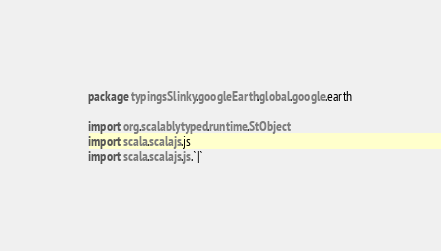<code> <loc_0><loc_0><loc_500><loc_500><_Scala_>package typingsSlinky.googleEarth.global.google.earth

import org.scalablytyped.runtime.StObject
import scala.scalajs.js
import scala.scalajs.js.`|`</code> 